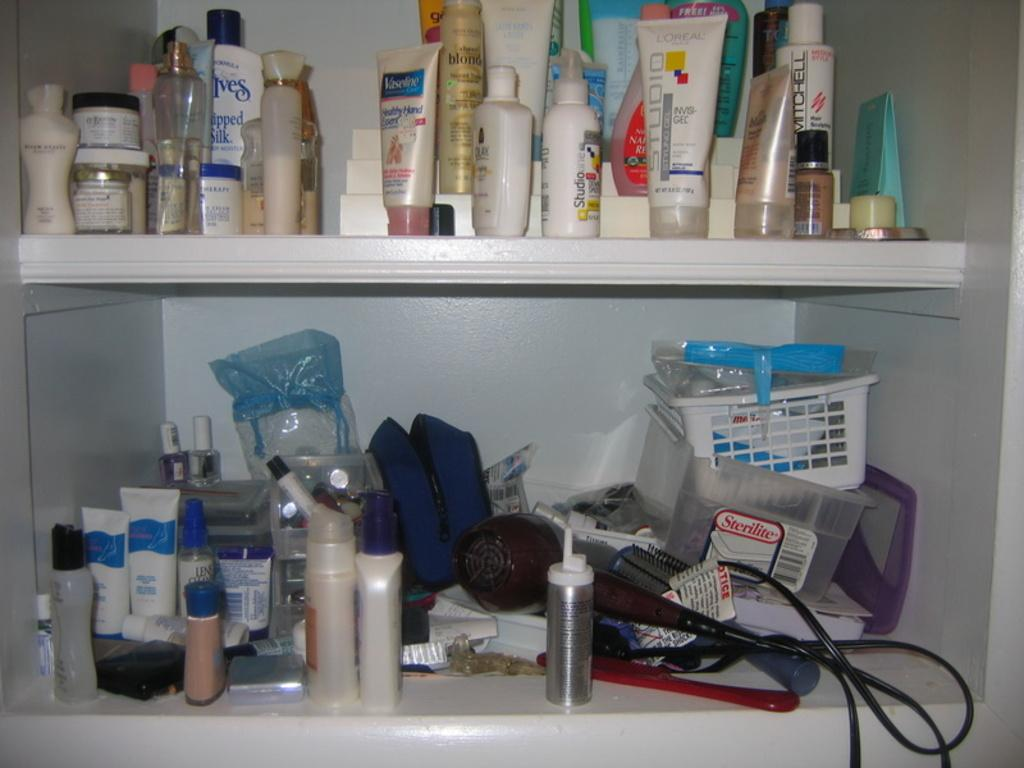<image>
Give a short and clear explanation of the subsequent image. A messy closet contains several lotions such as Vaseline and L'Oreal. 